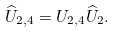<formula> <loc_0><loc_0><loc_500><loc_500>\widehat { U } _ { 2 , 4 } = U _ { 2 , 4 } \widehat { U } _ { 2 } .</formula> 